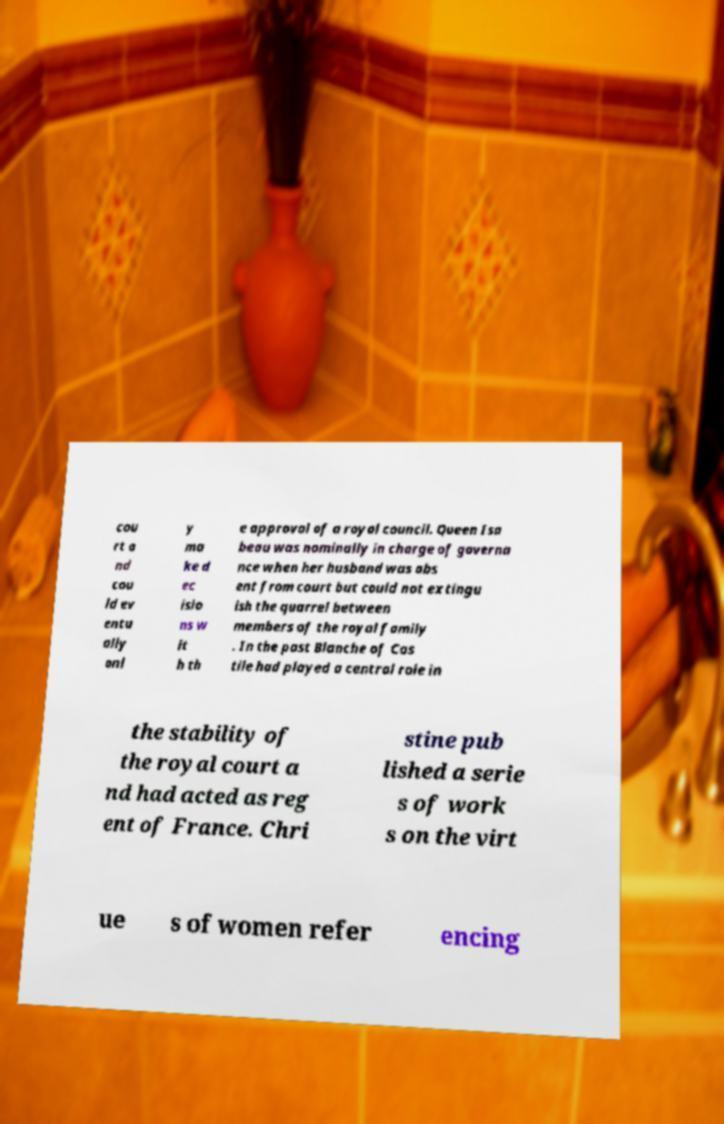Can you read and provide the text displayed in the image?This photo seems to have some interesting text. Can you extract and type it out for me? cou rt a nd cou ld ev entu ally onl y ma ke d ec isio ns w it h th e approval of a royal council. Queen Isa beau was nominally in charge of governa nce when her husband was abs ent from court but could not extingu ish the quarrel between members of the royal family . In the past Blanche of Cas tile had played a central role in the stability of the royal court a nd had acted as reg ent of France. Chri stine pub lished a serie s of work s on the virt ue s of women refer encing 